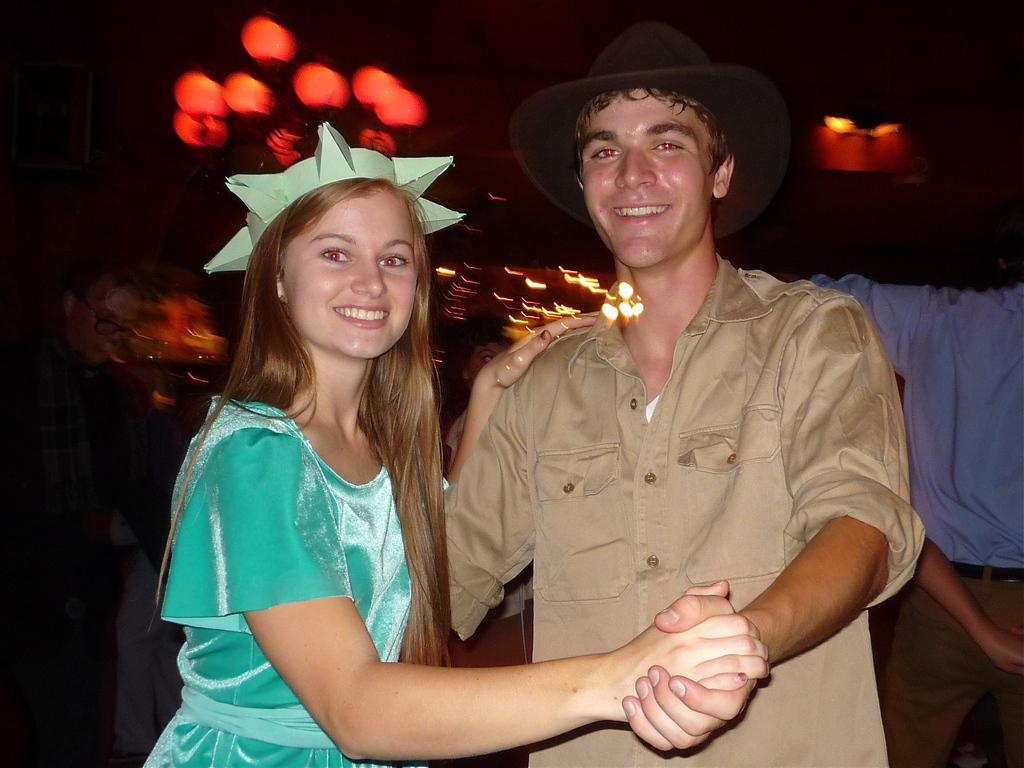Who are the two people in the center of the image? There is a man and a woman standing in the center of the image. What can be seen in the background of the image? There are lights, a person, cloth, and a wall visible in the background of the image. What type of guitar is the person in the background playing in the image? There is no guitar present in the image; only the man, the woman, and the background elements are visible. 